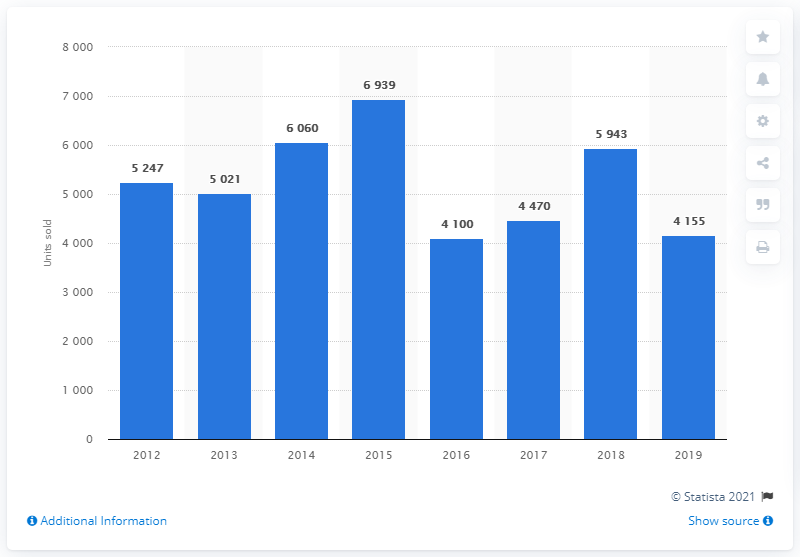Indicate a few pertinent items in this graphic. In 2015, the highest number of Volvo cars sold in Turkey was 6,939. 